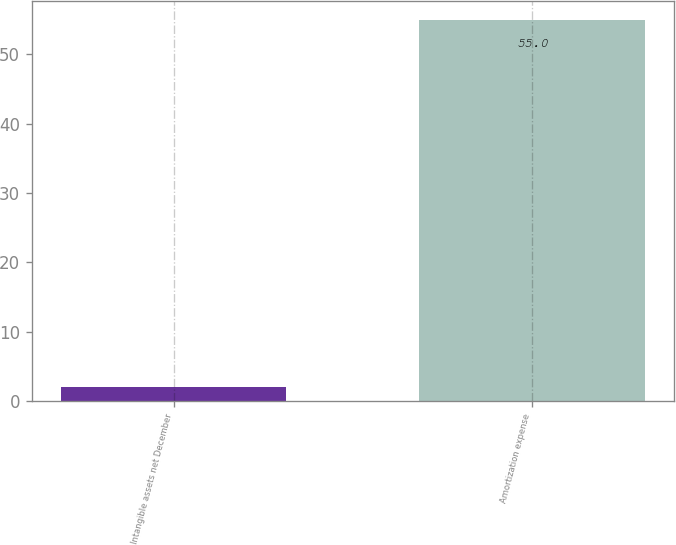Convert chart to OTSL. <chart><loc_0><loc_0><loc_500><loc_500><bar_chart><fcel>Intangible assets net December<fcel>Amortization expense<nl><fcel>2<fcel>55<nl></chart> 